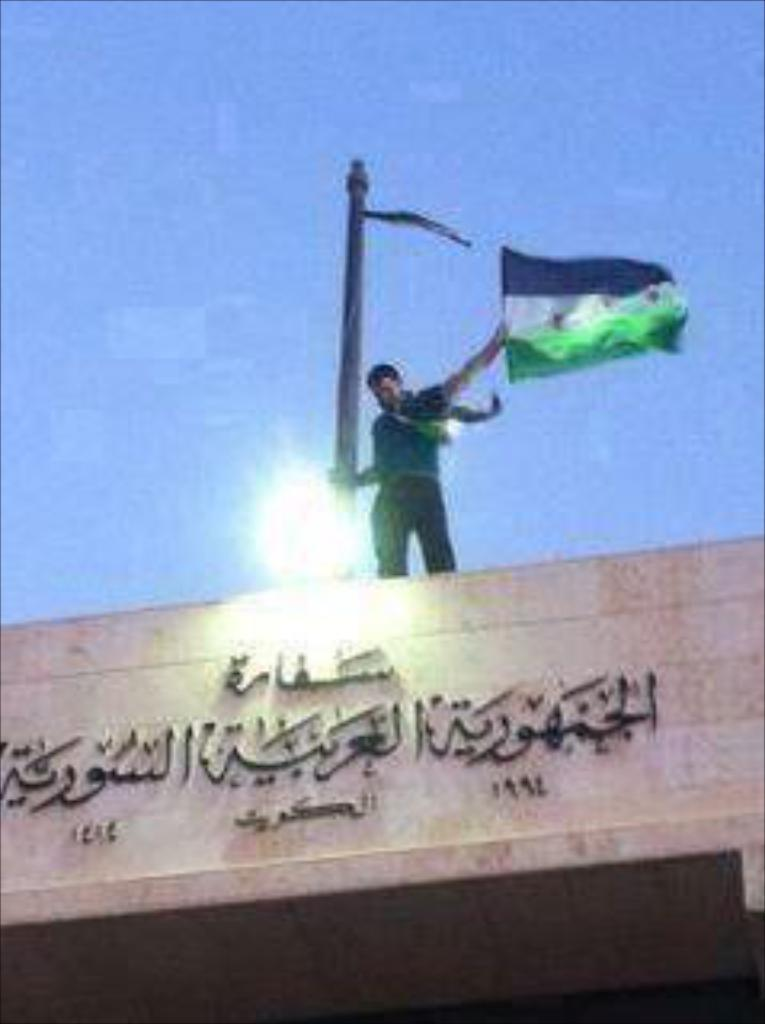What is the person in the image doing? The person is standing on the top of the building. What is the person holding in the image? The person is holding a pole. What is attached to the pole? There is a flag on the pole. What can be seen on the building? There is text on the building. What is visible at the top of the image? The sky is visible at the top of the image. Can you see any fog in the image? There is no mention of fog in the image, so we cannot determine if it is present or not. Is there a baseball game happening in the image? There is no indication of a baseball game or any sports-related activity in the image. 